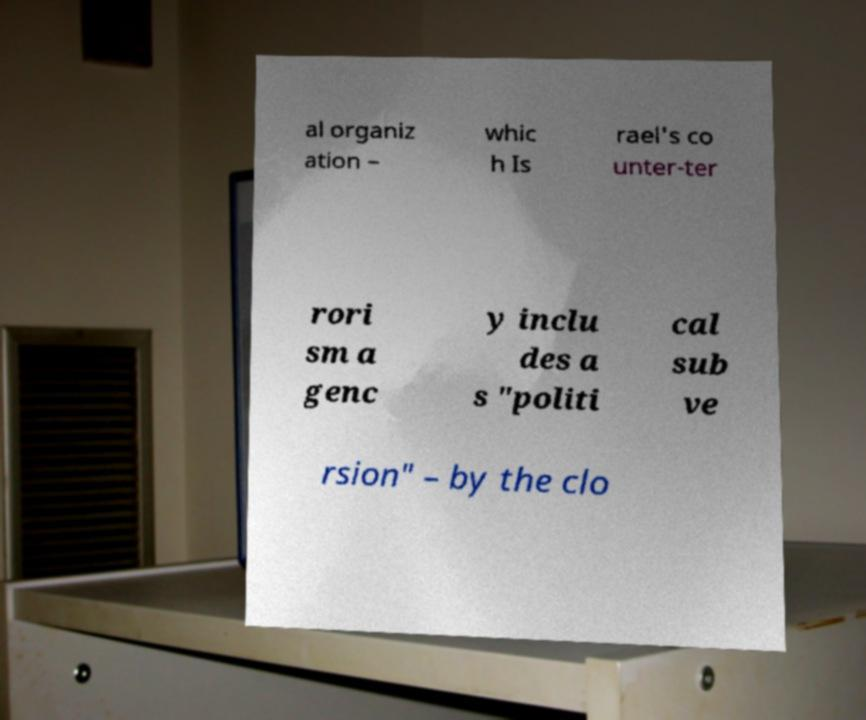Please read and relay the text visible in this image. What does it say? al organiz ation – whic h Is rael's co unter-ter rori sm a genc y inclu des a s "politi cal sub ve rsion" – by the clo 